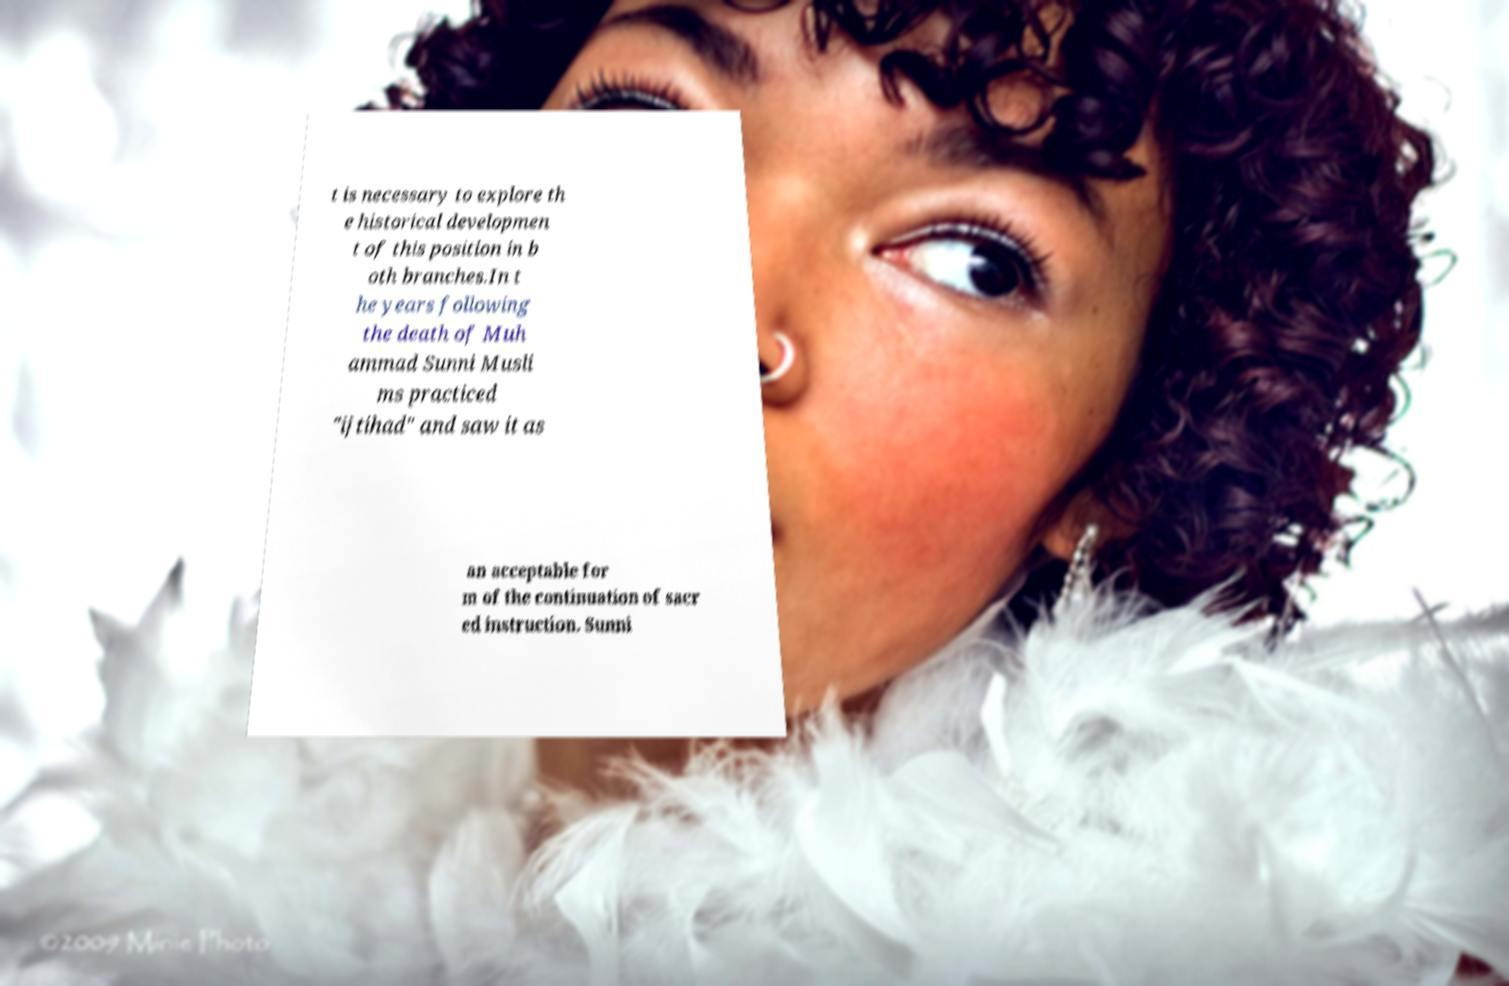Can you accurately transcribe the text from the provided image for me? t is necessary to explore th e historical developmen t of this position in b oth branches.In t he years following the death of Muh ammad Sunni Musli ms practiced "ijtihad" and saw it as an acceptable for m of the continuation of sacr ed instruction. Sunni 